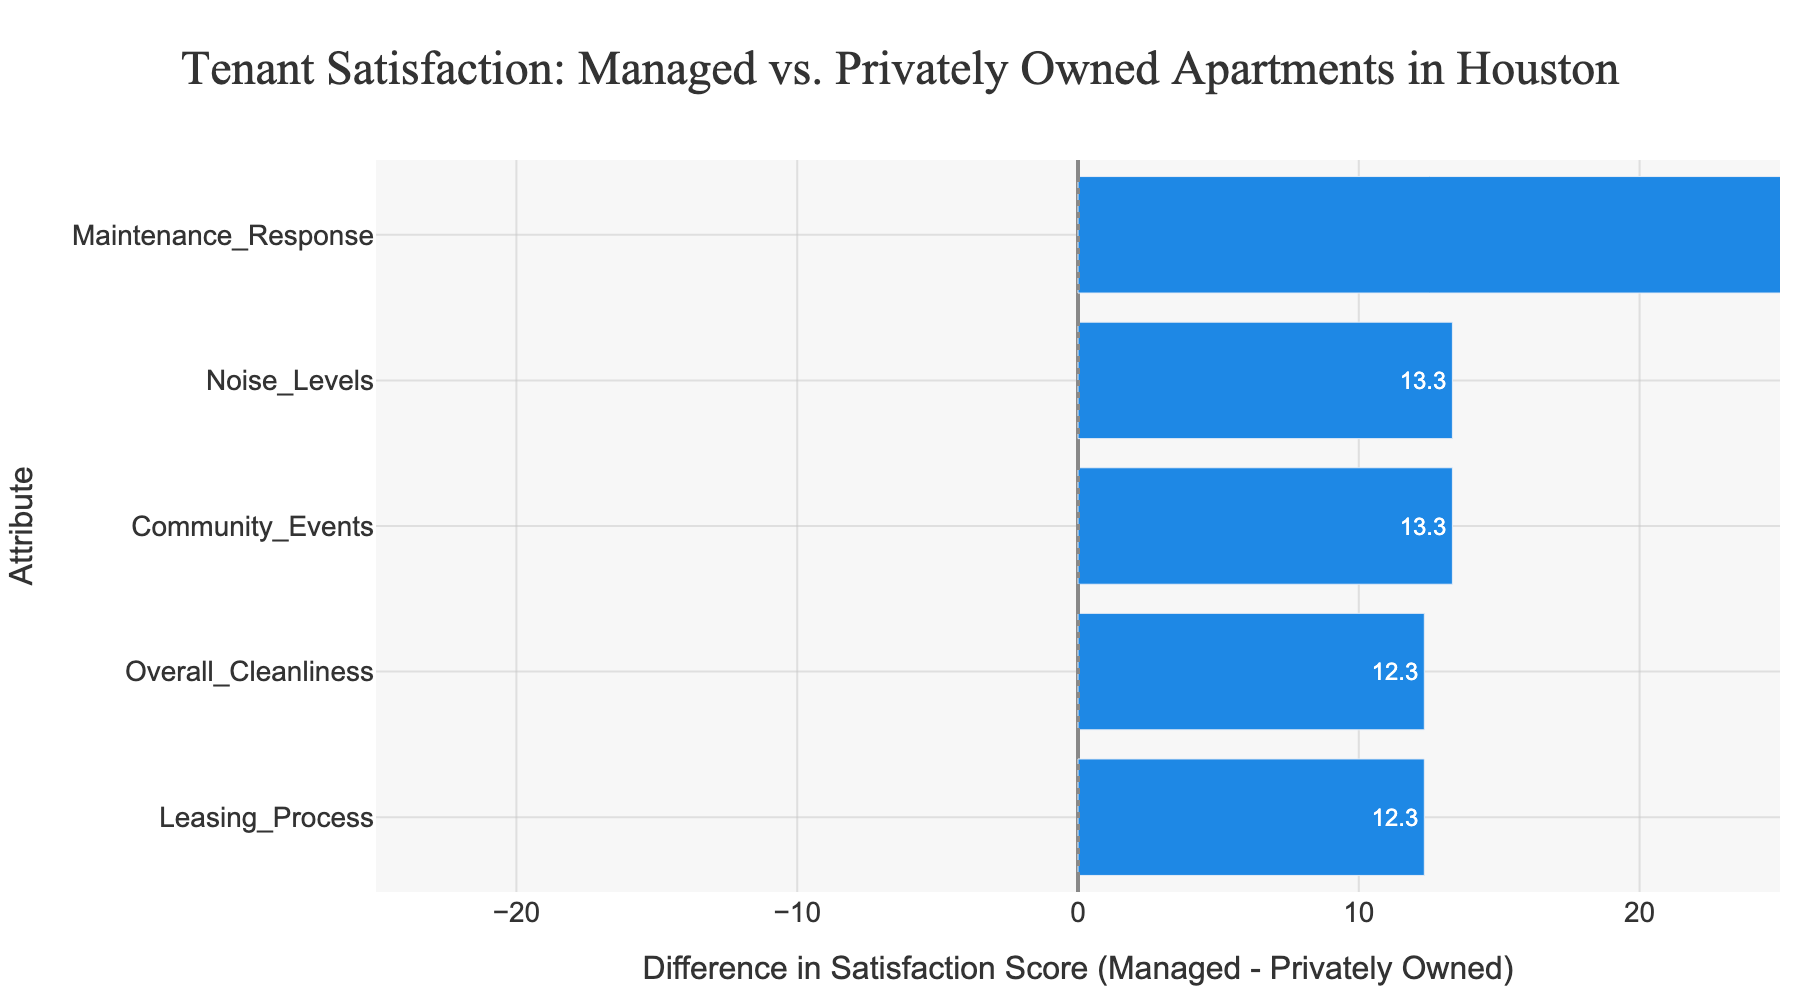How does tenant satisfaction compare between managed and privately owned apartments for the attribute of maintenance response? The bar for the maintenance response attribute shows a positive difference, indicating that managed apartments have a higher tenant satisfaction score compared to privately owned apartments. From the hover text, managed apartments have an average score of 87.7, and privately owned apartments have an average score of 60, resulting in a difference of 27.7.
Answer: Managed apartments have higher satisfaction by 27.7 points Which attribute has the smallest difference in tenant satisfaction scores between managed and privately owned apartments? The bar with the smallest difference is Leasing Process, which is slightly positive. This can be confirmed by the hover text indicating a very small difference.
Answer: Leasing Process Are there any attributes where privately owned apartments have higher tenant satisfaction than managed apartments? All the bars on the chart are colored blue, indicating that for all attributes, managed apartments have higher satisfaction scores compared to privately owned apartments.
Answer: No What is the average tenant satisfaction score for managed apartments across all attributes? Sum the average satisfaction scores for managed apartments for each attribute (Maintenance Response, Leasing Process, Overall Cleanliness, Community Events, Noise Levels) and then divide by the number of attributes: (87.7 + 78.3 + 77.5 + 67.5 + 80.8) / 5 = 391.8 / 5
Answer: 78.4 Which attribute shows the greatest difference in satisfaction scores and what is that difference? Maintenance response shows the greatest difference, with the hover text indicating a difference of 27.7.
Answer: Maintenance Response, 27.7 points How does the tenant satisfaction score for noise levels compare between managed and privately owned apartments? The difference bar for noise levels is positive, indicating higher satisfaction in managed apartments. From the hover text, managed apartments have an average score of 79.3, while privately owned apartments have a score of 70.3, resulting in a difference of 9.0.
Answer: Managed apartments have higher satisfaction by 9.0 points How much higher is the satisfaction score for community events in managed apartments compared to privately owned apartments? The bar for community events shows a positive difference. The hover text shows managed apartments have an average score of 66.7, while privately owned apartments have a score of 55.0, leading to a difference of 11.7 points.
Answer: 11.7 points Arrange the attributes in order of decreasing difference in tenant satisfaction scores. From the chart: Maintenance Response > Noise Levels > Overall Cleanliness > Community Events > Leasing Process.
Answer: Maintenance Response, Noise Levels, Overall Cleanliness, Community Events, Leasing Process Is there any attribute where the satisfaction score difference is less than 5 points? The Leasing Process attribute shows a very small difference, which is visible from the shorter bar and confirmed by the hover text showing a minimal difference.
Answer: Leasing Process 